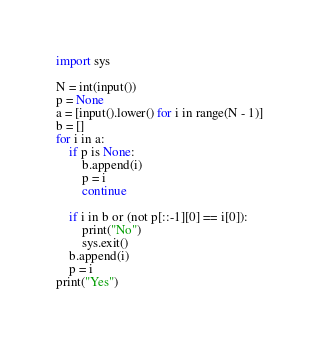<code> <loc_0><loc_0><loc_500><loc_500><_Python_>import sys

N = int(input())
p = None
a = [input().lower() for i in range(N - 1)]
b = []
for i in a:
    if p is None:
        b.append(i)
        p = i
        continue

    if i in b or (not p[::-1][0] == i[0]):
        print("No")
        sys.exit()
    b.append(i)
    p = i
print("Yes")</code> 